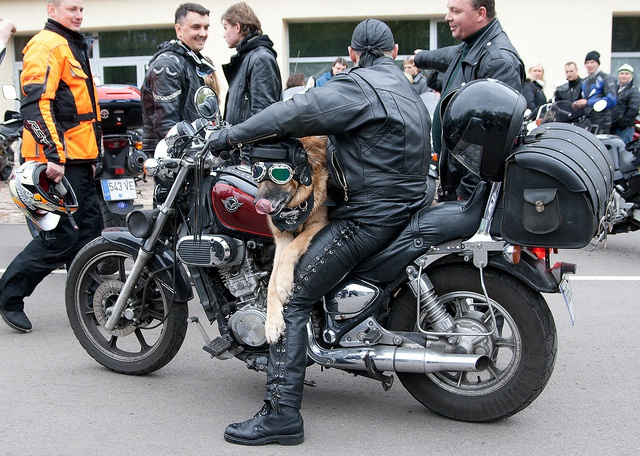Describe the objects in this image and their specific colors. I can see motorcycle in tan, black, gray, darkgray, and lightgray tones, people in tan, black, gray, and darkgray tones, people in tan, black, lightgray, gray, and orange tones, dog in tan, black, lightgray, gray, and darkgray tones, and people in tan, gray, black, and darkgray tones in this image. 